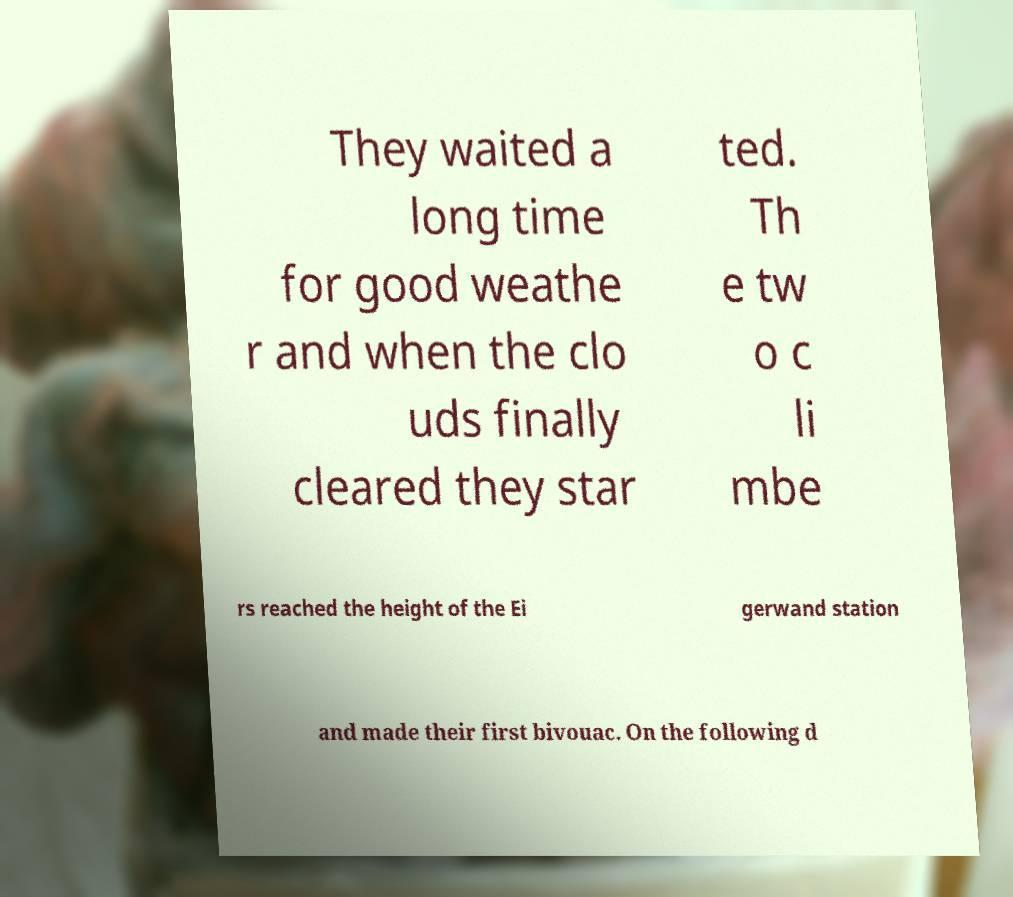There's text embedded in this image that I need extracted. Can you transcribe it verbatim? They waited a long time for good weathe r and when the clo uds finally cleared they star ted. Th e tw o c li mbe rs reached the height of the Ei gerwand station and made their first bivouac. On the following d 